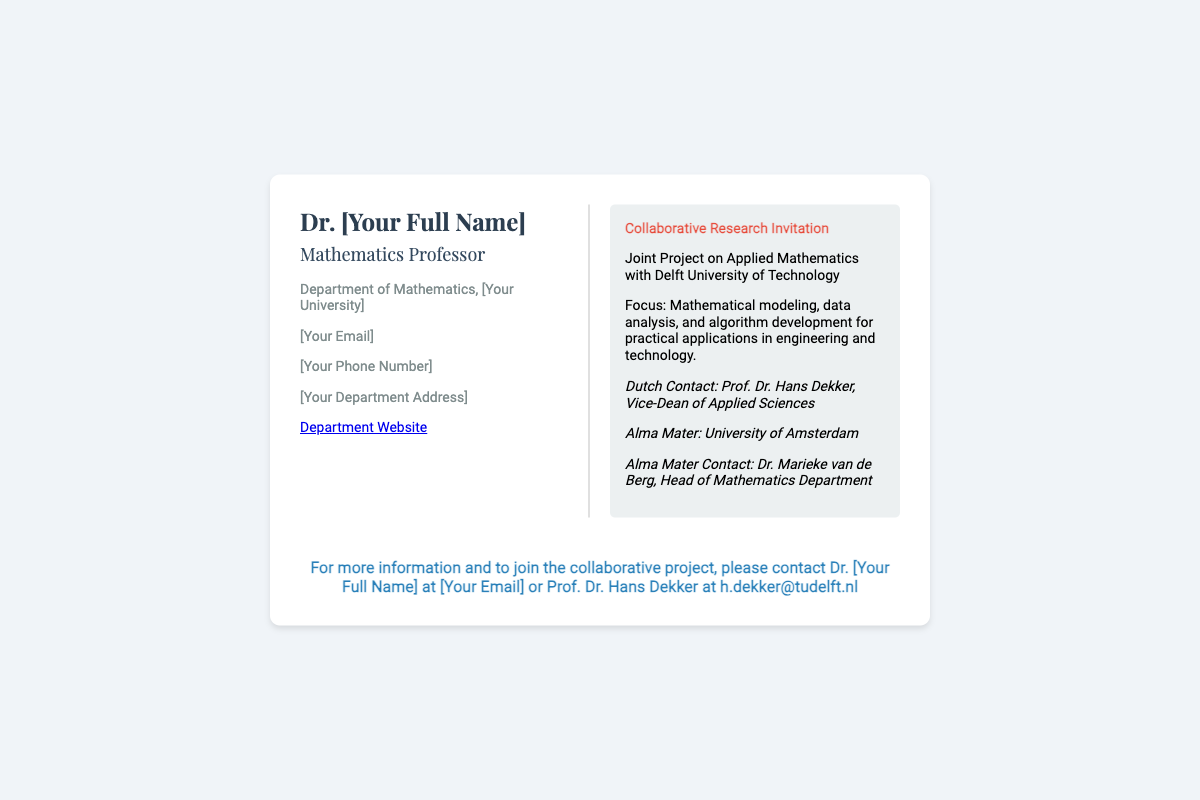What is the title of the project? The title of the project is stated prominently in the project information section of the document.
Answer: Collaborative Research Invitation Who is the Dutch contact? The Dutch contact is listed in the collaborators section of the project information.
Answer: Prof. Dr. Hans Dekker What is the focus of the joint project? The focus of the joint project is mentioned in the project description, outlining key areas of research.
Answer: Mathematical modeling, data analysis, and algorithm development Which university is featured as the alma mater? The alma mater is specified in the collaborators section, indicating the university associated with the professor.
Answer: University of Amsterdam What is the position of the Dutch contact? The position of the Dutch contact is provided alongside their name in the collaborators section.
Answer: Vice-Dean of Applied Sciences How can one join the collaborative project? The document provides a call to action, indicating how to participate in the project.
Answer: Contact Dr. [Your Full Name] at [Your Email] Who is the head of the mathematics department at the alma mater? The name and position of the head of the mathematics department is mentioned under collaborators.
Answer: Dr. Marieke van de Berg 